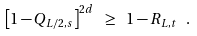<formula> <loc_0><loc_0><loc_500><loc_500>\left [ 1 - Q _ { L / 2 , s } \right ] ^ { 2 d } \ \geq \ 1 - R _ { L , t } \ .</formula> 